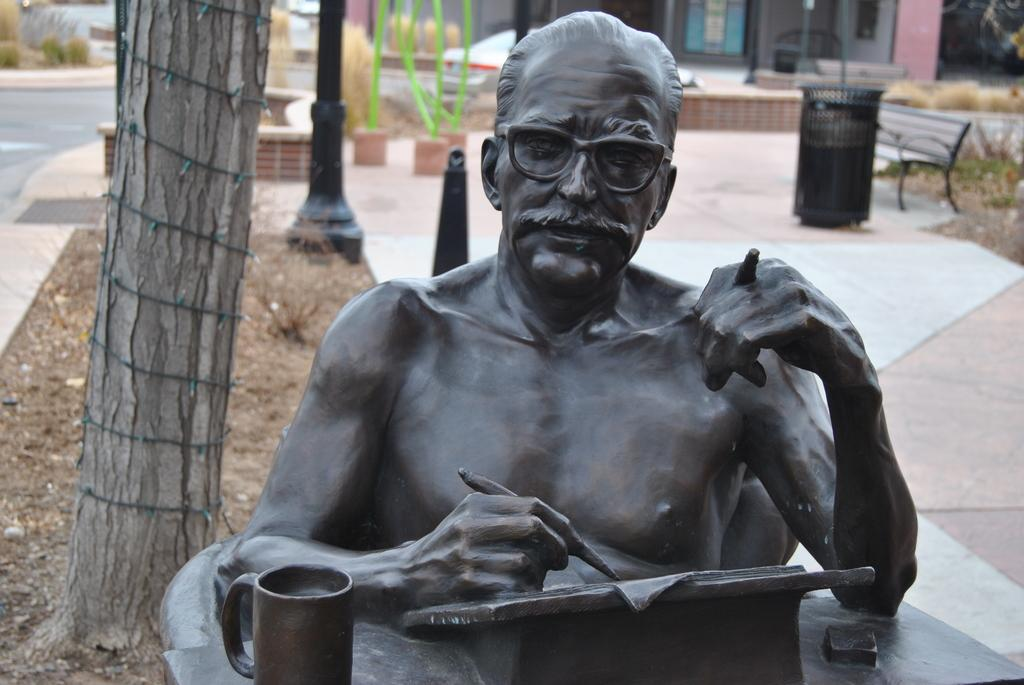What is the main subject in the image? There is a sculpture in the image. What type of natural elements can be seen in the image? There are trees in the image. What man-made object is present in the image? There is a pole in the image. What is used for waste disposal in the image? There is a bin in the image. What type of seating is available in the image? There is a bench in the image. What type of structure is visible in the image? There is a building in the image. What type of tent is set up near the sculpture in the image? There is no tent present in the image; it only features a sculpture, trees, a pole, a bin, a bench, and a building. 